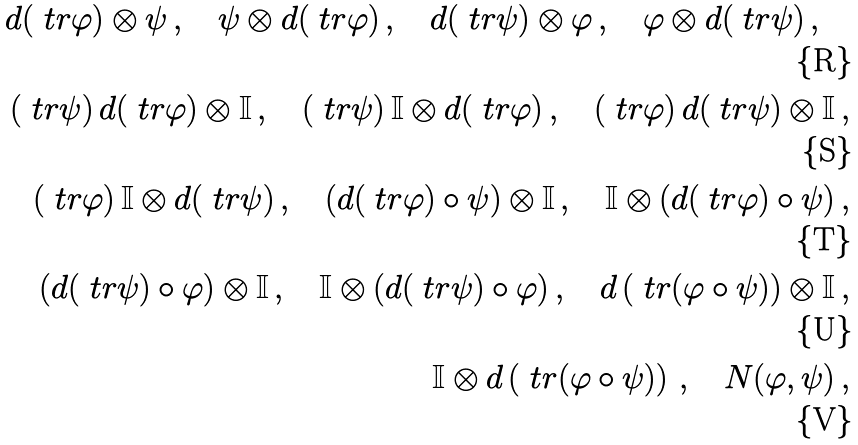Convert formula to latex. <formula><loc_0><loc_0><loc_500><loc_500>d ( \ t r \varphi ) \otimes \psi \, , \quad \psi \otimes d ( \ t r \varphi ) \, , \quad d ( \ t r \psi ) \otimes \varphi \, , \quad \varphi \otimes d ( \ t r \psi ) \, , \quad \\ ( \ t r \psi ) \, d ( \ t r \varphi ) \otimes \mathbb { I } \, , \quad ( \ t r \psi ) \, \mathbb { I } \otimes d ( \ t r \varphi ) \, , \quad ( \ t r \varphi ) \, d ( \ t r \psi ) \otimes \mathbb { I } \, , \\ ( \ t r \varphi ) \, \mathbb { I } \otimes d ( \ t r \psi ) \, , \quad ( d ( \ t r \varphi ) \circ \psi ) \otimes \mathbb { I } \, , \quad \mathbb { I } \otimes ( d ( \ t r \varphi ) \circ \psi ) \, , \\ ( d ( \ t r \psi ) \circ \varphi ) \otimes \mathbb { I } \, , \quad \mathbb { I } \otimes ( d ( \ t r \psi ) \circ \varphi ) \, , \quad d \left ( \ t r ( \varphi \circ \psi ) \right ) \otimes \mathbb { I } \, , \\ \mathbb { I } \otimes d \left ( \ t r ( \varphi \circ \psi ) \right ) \, , \quad N ( \varphi , \psi ) \, ,</formula> 